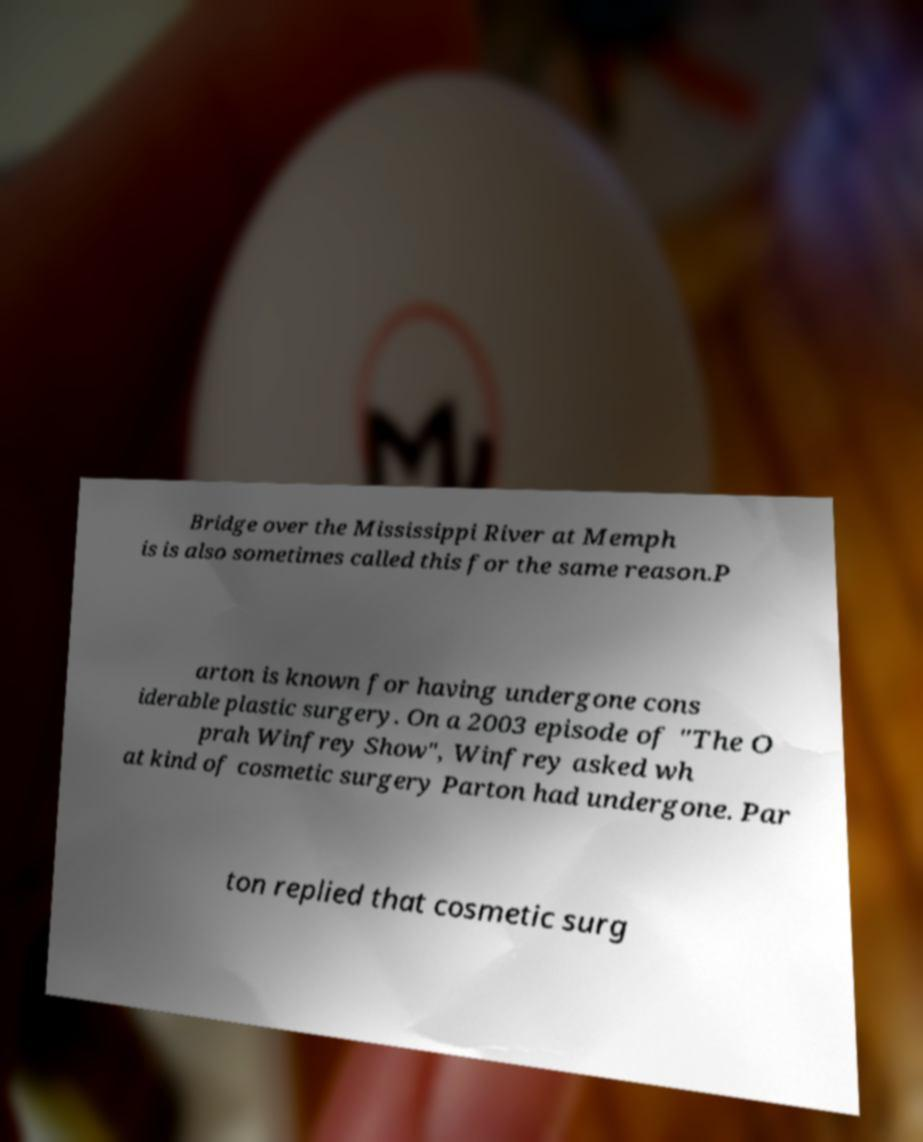Could you extract and type out the text from this image? Bridge over the Mississippi River at Memph is is also sometimes called this for the same reason.P arton is known for having undergone cons iderable plastic surgery. On a 2003 episode of "The O prah Winfrey Show", Winfrey asked wh at kind of cosmetic surgery Parton had undergone. Par ton replied that cosmetic surg 